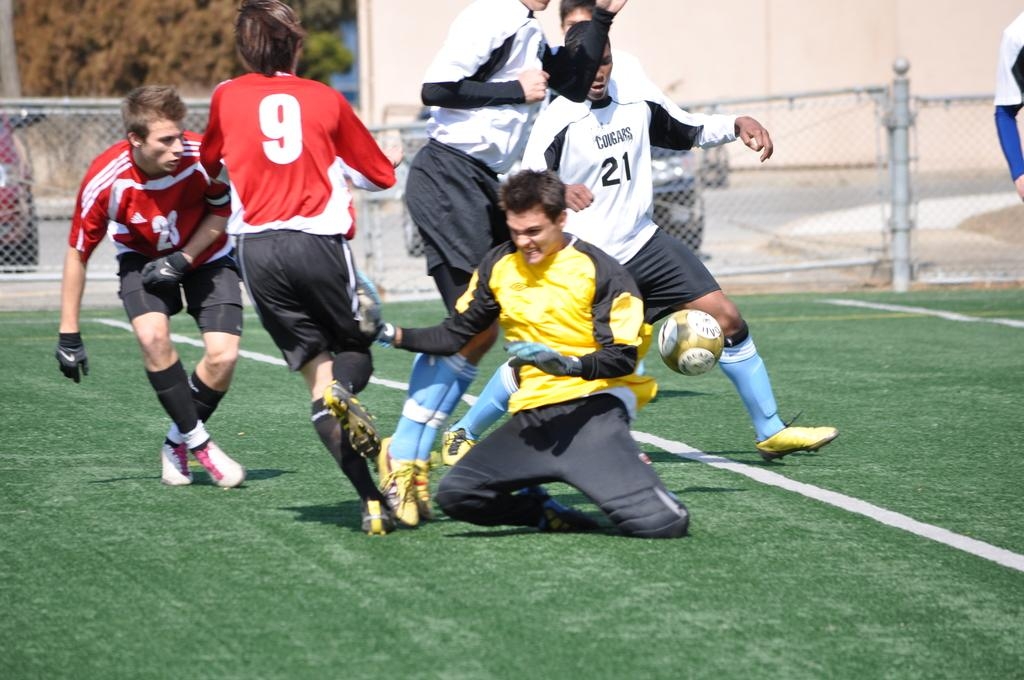<image>
Summarize the visual content of the image. A group of soccer players compete and number 21 is about the strike the ball. 